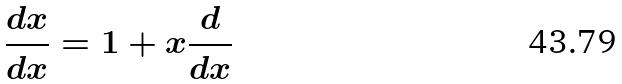Convert formula to latex. <formula><loc_0><loc_0><loc_500><loc_500>\frac { d x } { d x } = 1 + x \frac { d } { d x }</formula> 